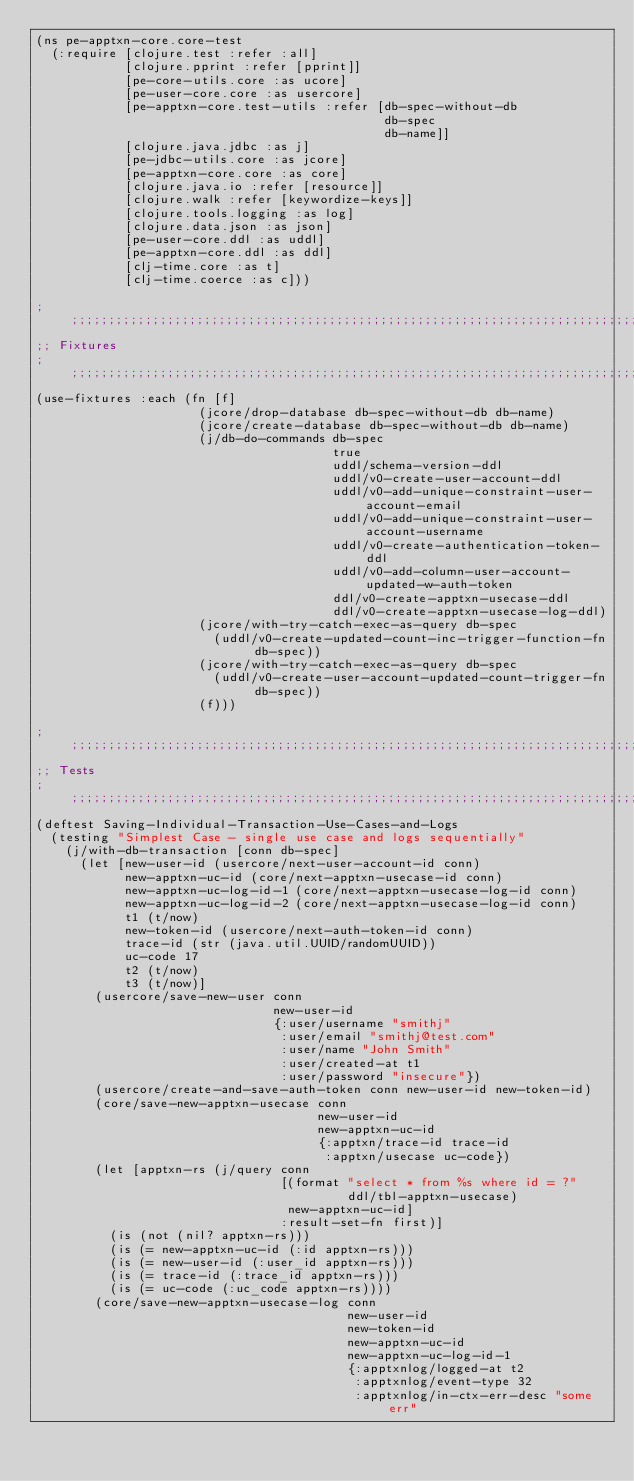<code> <loc_0><loc_0><loc_500><loc_500><_Clojure_>(ns pe-apptxn-core.core-test
  (:require [clojure.test :refer :all]
            [clojure.pprint :refer [pprint]]
            [pe-core-utils.core :as ucore]
            [pe-user-core.core :as usercore]
            [pe-apptxn-core.test-utils :refer [db-spec-without-db
                                               db-spec
                                               db-name]]
            [clojure.java.jdbc :as j]
            [pe-jdbc-utils.core :as jcore]
            [pe-apptxn-core.core :as core]
            [clojure.java.io :refer [resource]]
            [clojure.walk :refer [keywordize-keys]]
            [clojure.tools.logging :as log]
            [clojure.data.json :as json]
            [pe-user-core.ddl :as uddl]
            [pe-apptxn-core.ddl :as ddl]
            [clj-time.core :as t]
            [clj-time.coerce :as c]))

;;;;;;;;;;;;;;;;;;;;;;;;;;;;;;;;;;;;;;;;;;;;;;;;;;;;;;;;;;;;;;;;;;;;;;;;;;;;;;;;
;; Fixtures
;;;;;;;;;;;;;;;;;;;;;;;;;;;;;;;;;;;;;;;;;;;;;;;;;;;;;;;;;;;;;;;;;;;;;;;;;;;;;;;;
(use-fixtures :each (fn [f]
                      (jcore/drop-database db-spec-without-db db-name)
                      (jcore/create-database db-spec-without-db db-name)
                      (j/db-do-commands db-spec
                                        true
                                        uddl/schema-version-ddl
                                        uddl/v0-create-user-account-ddl
                                        uddl/v0-add-unique-constraint-user-account-email
                                        uddl/v0-add-unique-constraint-user-account-username
                                        uddl/v0-create-authentication-token-ddl
                                        uddl/v0-add-column-user-account-updated-w-auth-token
                                        ddl/v0-create-apptxn-usecase-ddl
                                        ddl/v0-create-apptxn-usecase-log-ddl)
                      (jcore/with-try-catch-exec-as-query db-spec
                        (uddl/v0-create-updated-count-inc-trigger-function-fn db-spec))
                      (jcore/with-try-catch-exec-as-query db-spec
                        (uddl/v0-create-user-account-updated-count-trigger-fn db-spec))
                      (f)))

;;;;;;;;;;;;;;;;;;;;;;;;;;;;;;;;;;;;;;;;;;;;;;;;;;;;;;;;;;;;;;;;;;;;;;;;;;;;;;;;
;; Tests
;;;;;;;;;;;;;;;;;;;;;;;;;;;;;;;;;;;;;;;;;;;;;;;;;;;;;;;;;;;;;;;;;;;;;;;;;;;;;;;;
(deftest Saving-Individual-Transaction-Use-Cases-and-Logs
  (testing "Simplest Case - single use case and logs sequentially"
    (j/with-db-transaction [conn db-spec]
      (let [new-user-id (usercore/next-user-account-id conn)
            new-apptxn-uc-id (core/next-apptxn-usecase-id conn)
            new-apptxn-uc-log-id-1 (core/next-apptxn-usecase-log-id conn)
            new-apptxn-uc-log-id-2 (core/next-apptxn-usecase-log-id conn)
            t1 (t/now)
            new-token-id (usercore/next-auth-token-id conn)
            trace-id (str (java.util.UUID/randomUUID))
            uc-code 17
            t2 (t/now)
            t3 (t/now)]
        (usercore/save-new-user conn
                                new-user-id
                                {:user/username "smithj"
                                 :user/email "smithj@test.com"
                                 :user/name "John Smith"
                                 :user/created-at t1
                                 :user/password "insecure"})
        (usercore/create-and-save-auth-token conn new-user-id new-token-id)
        (core/save-new-apptxn-usecase conn
                                      new-user-id
                                      new-apptxn-uc-id
                                      {:apptxn/trace-id trace-id
                                       :apptxn/usecase uc-code})
        (let [apptxn-rs (j/query conn
                                 [(format "select * from %s where id = ?"
                                          ddl/tbl-apptxn-usecase)
                                  new-apptxn-uc-id]
                                 :result-set-fn first)]
          (is (not (nil? apptxn-rs)))
          (is (= new-apptxn-uc-id (:id apptxn-rs)))
          (is (= new-user-id (:user_id apptxn-rs)))
          (is (= trace-id (:trace_id apptxn-rs)))
          (is (= uc-code (:uc_code apptxn-rs))))
        (core/save-new-apptxn-usecase-log conn
                                          new-user-id
                                          new-token-id
                                          new-apptxn-uc-id
                                          new-apptxn-uc-log-id-1
                                          {:apptxnlog/logged-at t2
                                           :apptxnlog/event-type 32
                                           :apptxnlog/in-ctx-err-desc "some err"</code> 